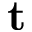Convert formula to latex. <formula><loc_0><loc_0><loc_500><loc_500>t</formula> 